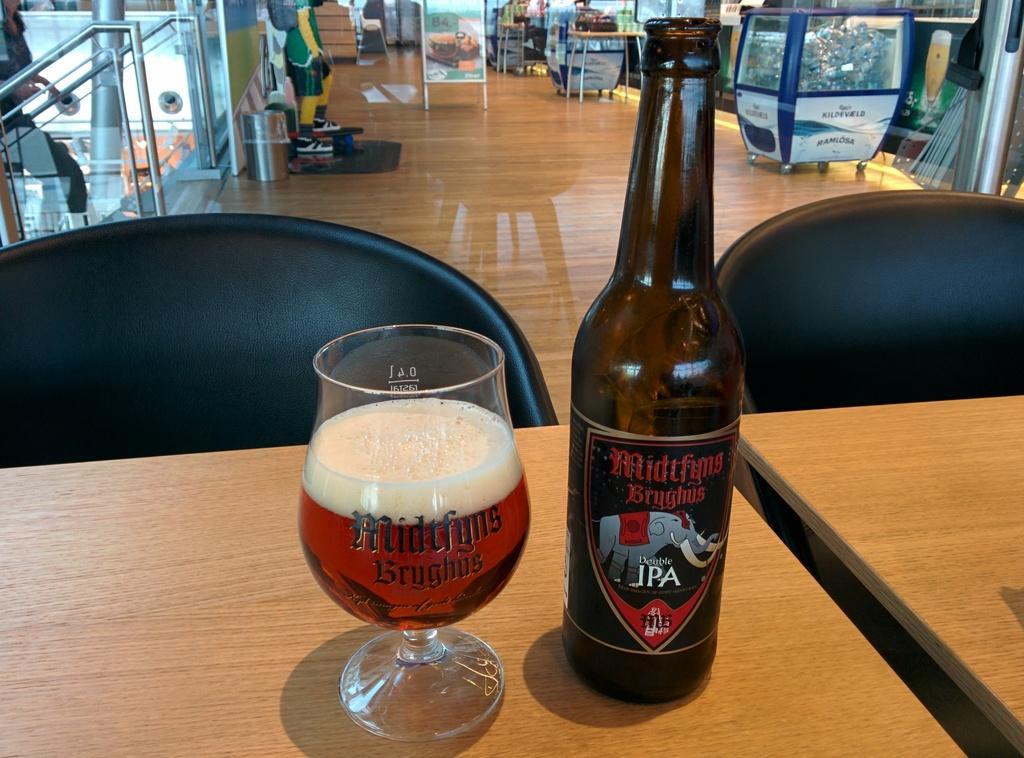<image>
Share a concise interpretation of the image provided. A bottle of Midtfyns Bryghus Double IPA next to a 1/2 full glass. 